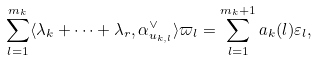<formula> <loc_0><loc_0><loc_500><loc_500>\sum _ { l = 1 } ^ { m _ { k } } \langle \lambda _ { k } + \cdots + \lambda _ { r } , \alpha _ { u _ { k , l } } ^ { \vee } \rangle \varpi _ { l } = \sum _ { l = 1 } ^ { m _ { k } + 1 } a _ { k } ( l ) \varepsilon _ { l } ,</formula> 